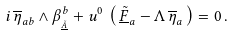<formula> <loc_0><loc_0><loc_500><loc_500>i \, \overline { \eta } _ { a b } \wedge \beta ^ { b } _ { _ { \underline { \tilde { A } } } } + u ^ { 0 } \, \left ( \, \underline { \tilde { F } } _ { a } - \Lambda \, \overline { \eta } _ { a } \, \right ) = 0 \, .</formula> 